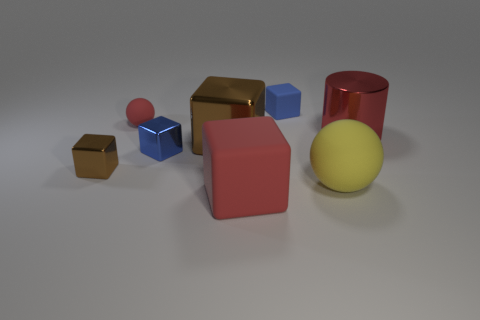Subtract all red blocks. How many blocks are left? 4 Subtract all tiny blue metal blocks. How many blocks are left? 4 Subtract all green blocks. Subtract all green cylinders. How many blocks are left? 5 Add 1 gray balls. How many objects exist? 9 Subtract all cubes. How many objects are left? 3 Add 3 brown things. How many brown things exist? 5 Subtract 0 green cylinders. How many objects are left? 8 Subtract all big metallic objects. Subtract all big brown shiny things. How many objects are left? 5 Add 5 tiny brown metallic blocks. How many tiny brown metallic blocks are left? 6 